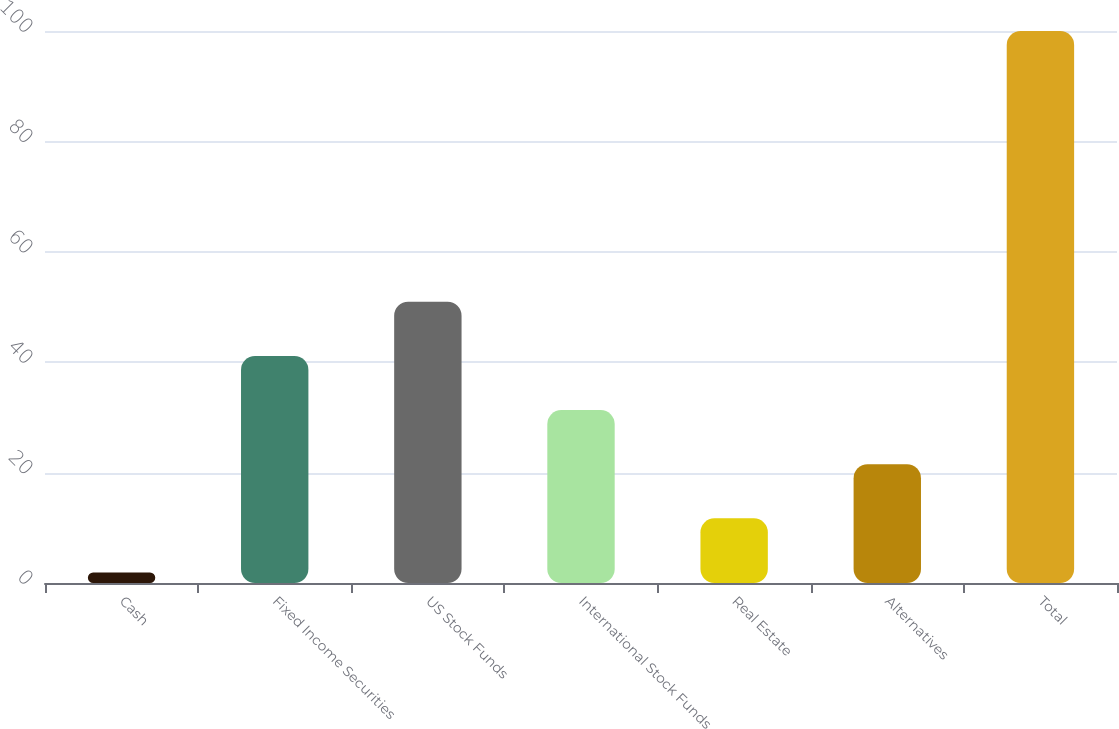<chart> <loc_0><loc_0><loc_500><loc_500><bar_chart><fcel>Cash<fcel>Fixed Income Securities<fcel>US Stock Funds<fcel>International Stock Funds<fcel>Real Estate<fcel>Alternatives<fcel>Total<nl><fcel>1.9<fcel>41.14<fcel>50.95<fcel>31.33<fcel>11.71<fcel>21.52<fcel>100<nl></chart> 